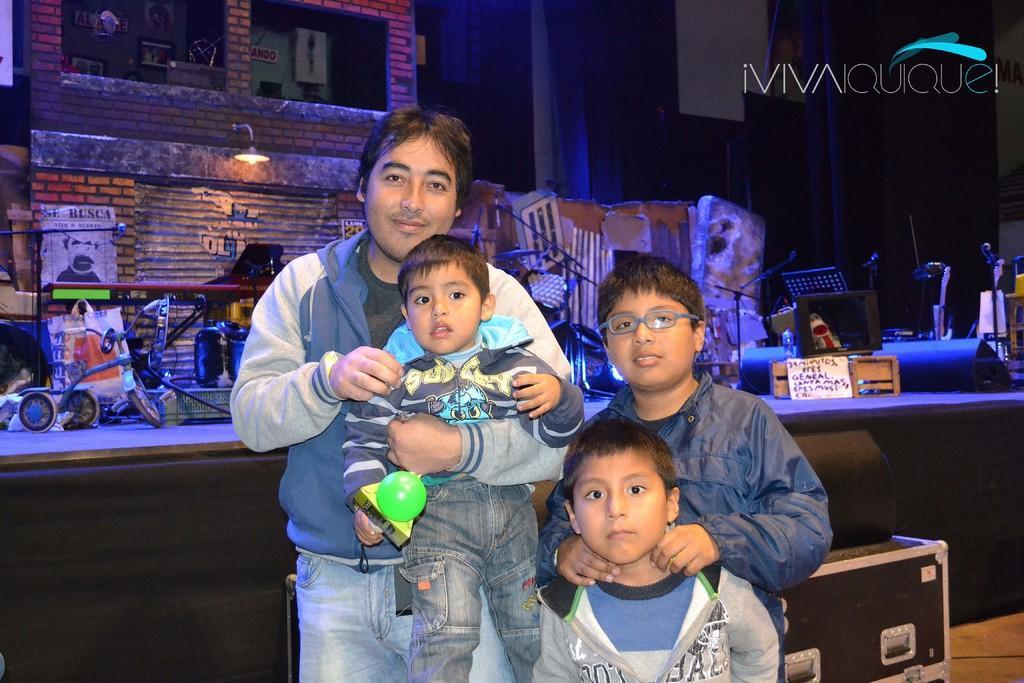Can you describe this image briefly? This picture describes about group of people, behind them we can see few boxes, toys, lights and other things, on top of the image we can see some text, also we can find a poster on the wall. 